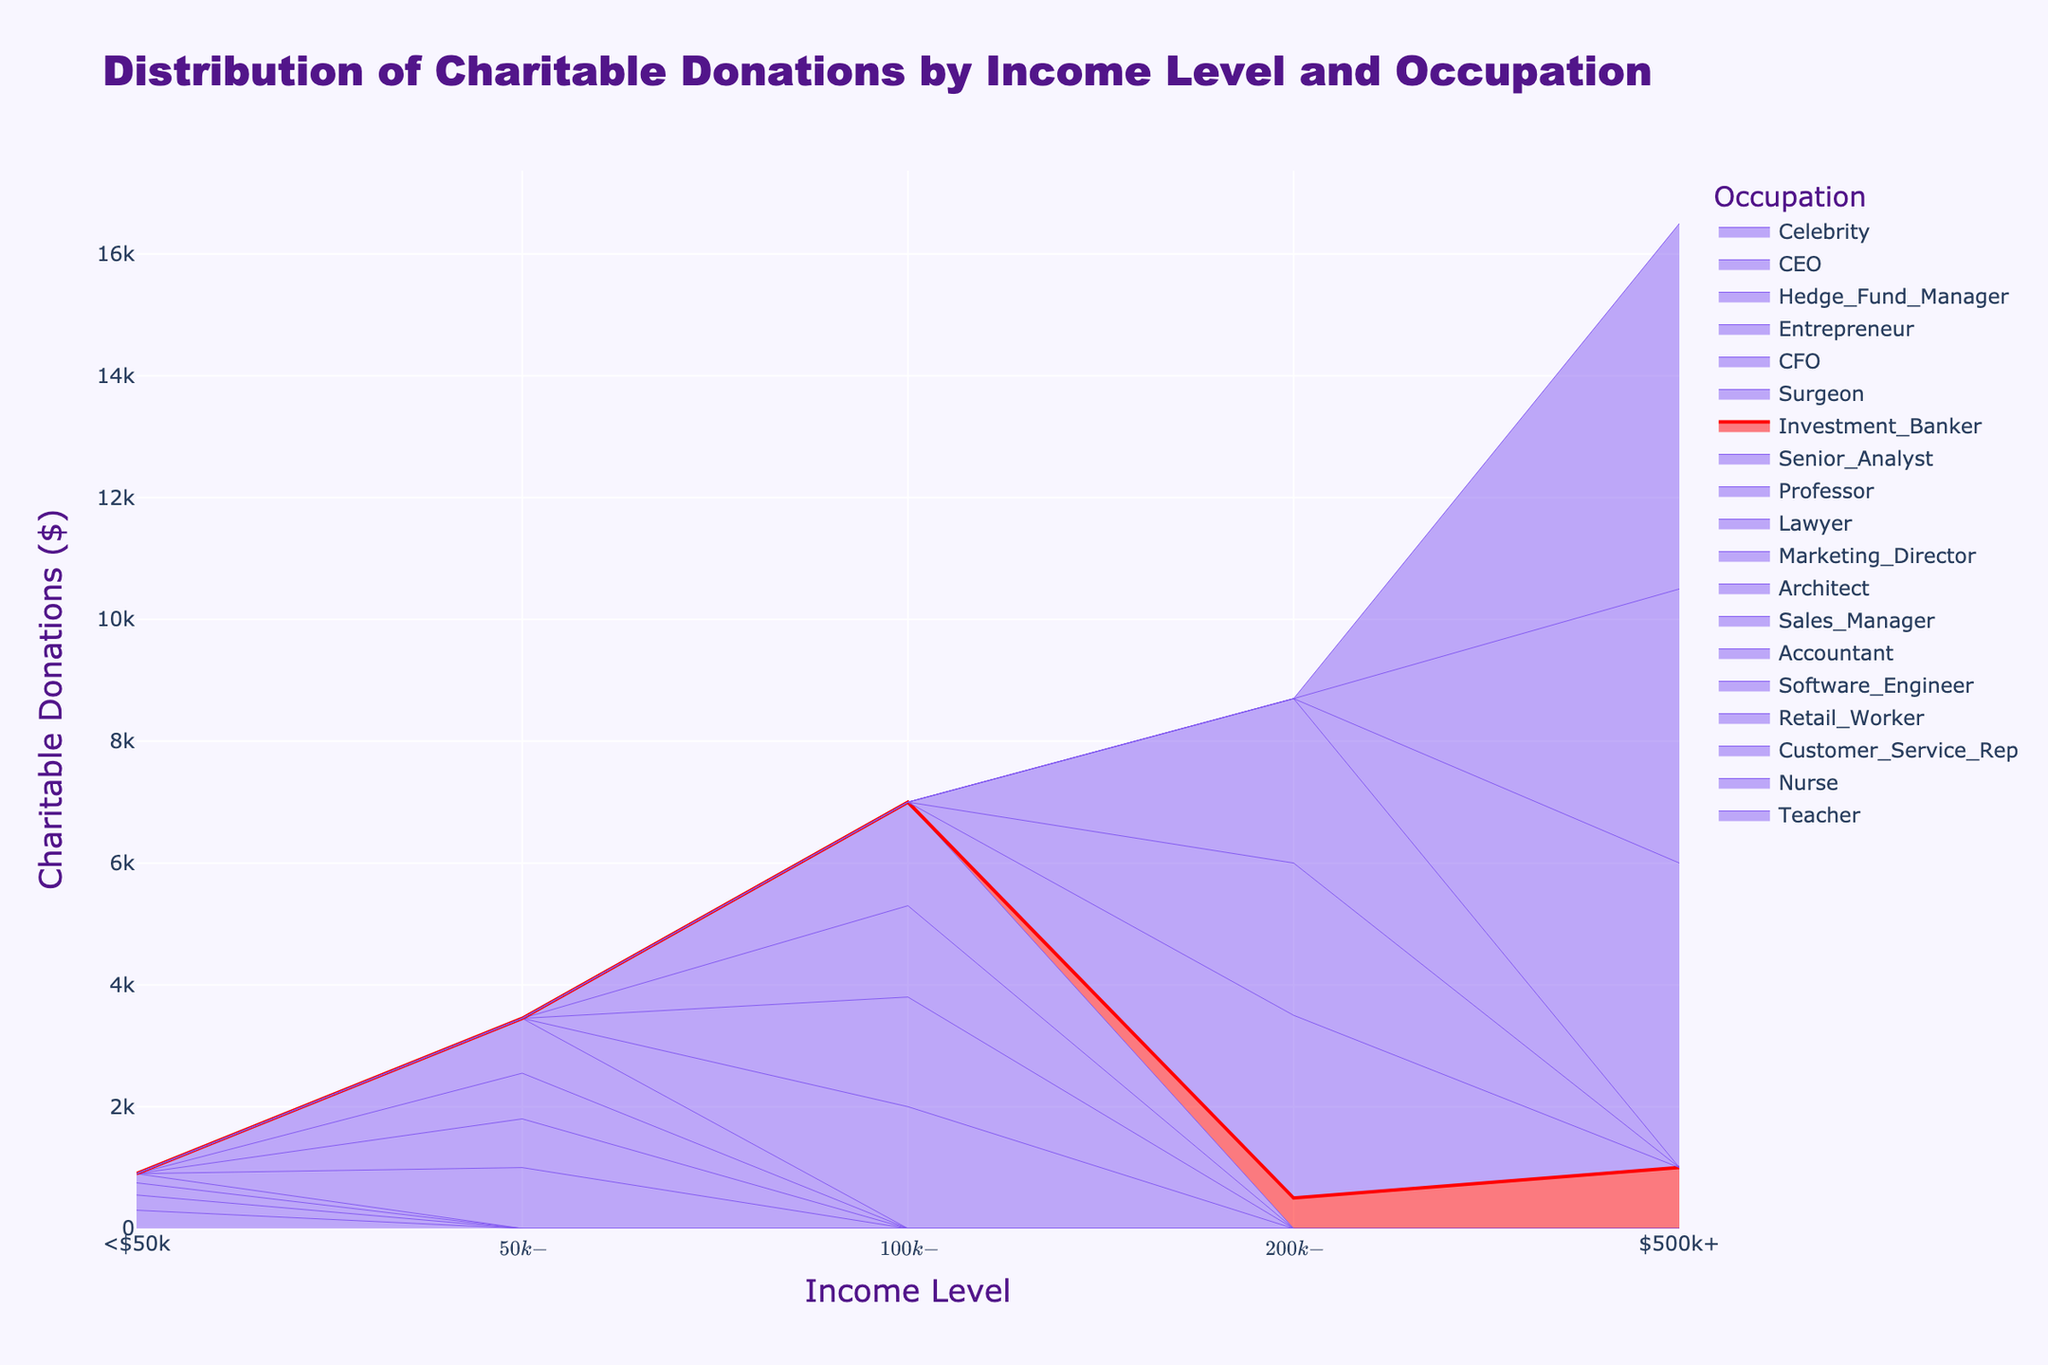What's the title of the figure? The title of the figure is located at the top and indicates the overall subject or theme of the data displayed.
Answer: Distribution of Charitable Donations by Income Level and Occupation What is the charitable donation amount from a Retail Worker earning less than $50k? To find this, locate the <$50k income level and find the line corresponding to Retail Workers.
Answer: 150 How does the charitable donation from an Investment Banker earning $200k-$500k compare to that of a Surgeon in the same income level? Identify both occupations at the $200k-$500k level and compare their donation amounts: Investment Banker ($500) vs. Surgeon ($3000).
Answer: Surgeon's donations are significantly higher What's the sum of charitable donations from Investment Bankers in both $200k-$500k and $500k+ income levels? Add the donations from Investment Bankers in both income levels: $500 + $1000.
Answer: 1500 Are Hedge Fund Managers or CEOs contributing more to charity in the $500k+ income level? Compare the donations of Hedge Fund Managers and CEOs in the $500k+ category.
Answer: Hedge Fund Managers Which occupation contributes the least amount to charity in the <$50k income level? Check all occupations listed under <$50k and identify the smallest donation amount.
Answer: Retail Worker What's the difference in charitable donations between a Marketing Director and a Senior Analyst in the $100k-$200k income level? Subtract the Senior Analyst's donation amount from the Marketing Director's: $2000 - $1700.
Answer: 300 What's the average charitable donation of occupations within the $50k-$100k income level? Sum the donation amounts of all occupations in this category and divide by the number of occupations: (1000 + 800 + 750 + 900) / 4.
Answer: 862.5 Which income level has the highest overall charitable donations by summing all occupations? Sum the donations for each occupation within each income level and compare the totals.
Answer: $500k+ What trend can be observed in charitable donations from Investment Bankers as their income increases? Track the donation amounts of Investment Bankers across income levels (<$50k, $200k-$500k, $500k+) and observe the pattern.
Answer: Initially increases, then decreases 